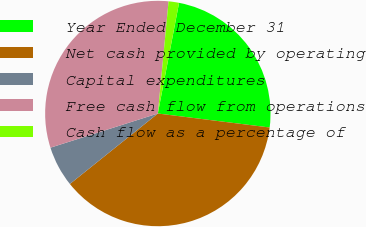Convert chart. <chart><loc_0><loc_0><loc_500><loc_500><pie_chart><fcel>Year Ended December 31<fcel>Net cash provided by operating<fcel>Capital expenditures<fcel>Free cash flow from operations<fcel>Cash flow as a percentage of<nl><fcel>23.96%<fcel>37.27%<fcel>5.85%<fcel>31.42%<fcel>1.5%<nl></chart> 